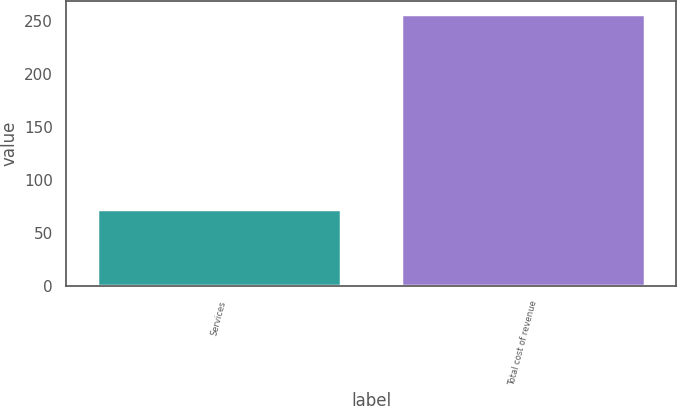Convert chart. <chart><loc_0><loc_0><loc_500><loc_500><bar_chart><fcel>Services<fcel>Total cost of revenue<nl><fcel>73.2<fcel>256.5<nl></chart> 